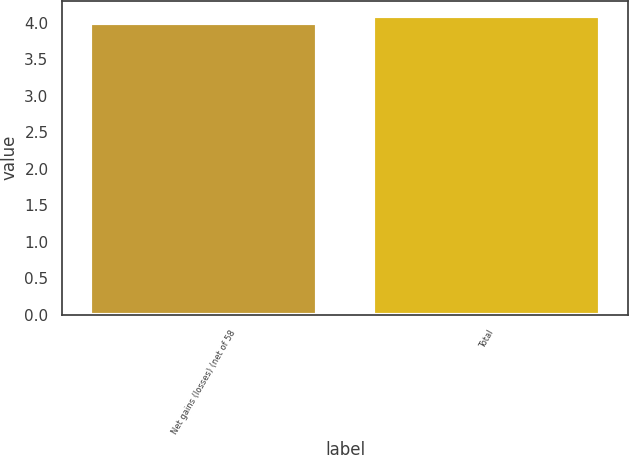Convert chart to OTSL. <chart><loc_0><loc_0><loc_500><loc_500><bar_chart><fcel>Net gains (losses) (net of 58<fcel>Total<nl><fcel>4<fcel>4.1<nl></chart> 